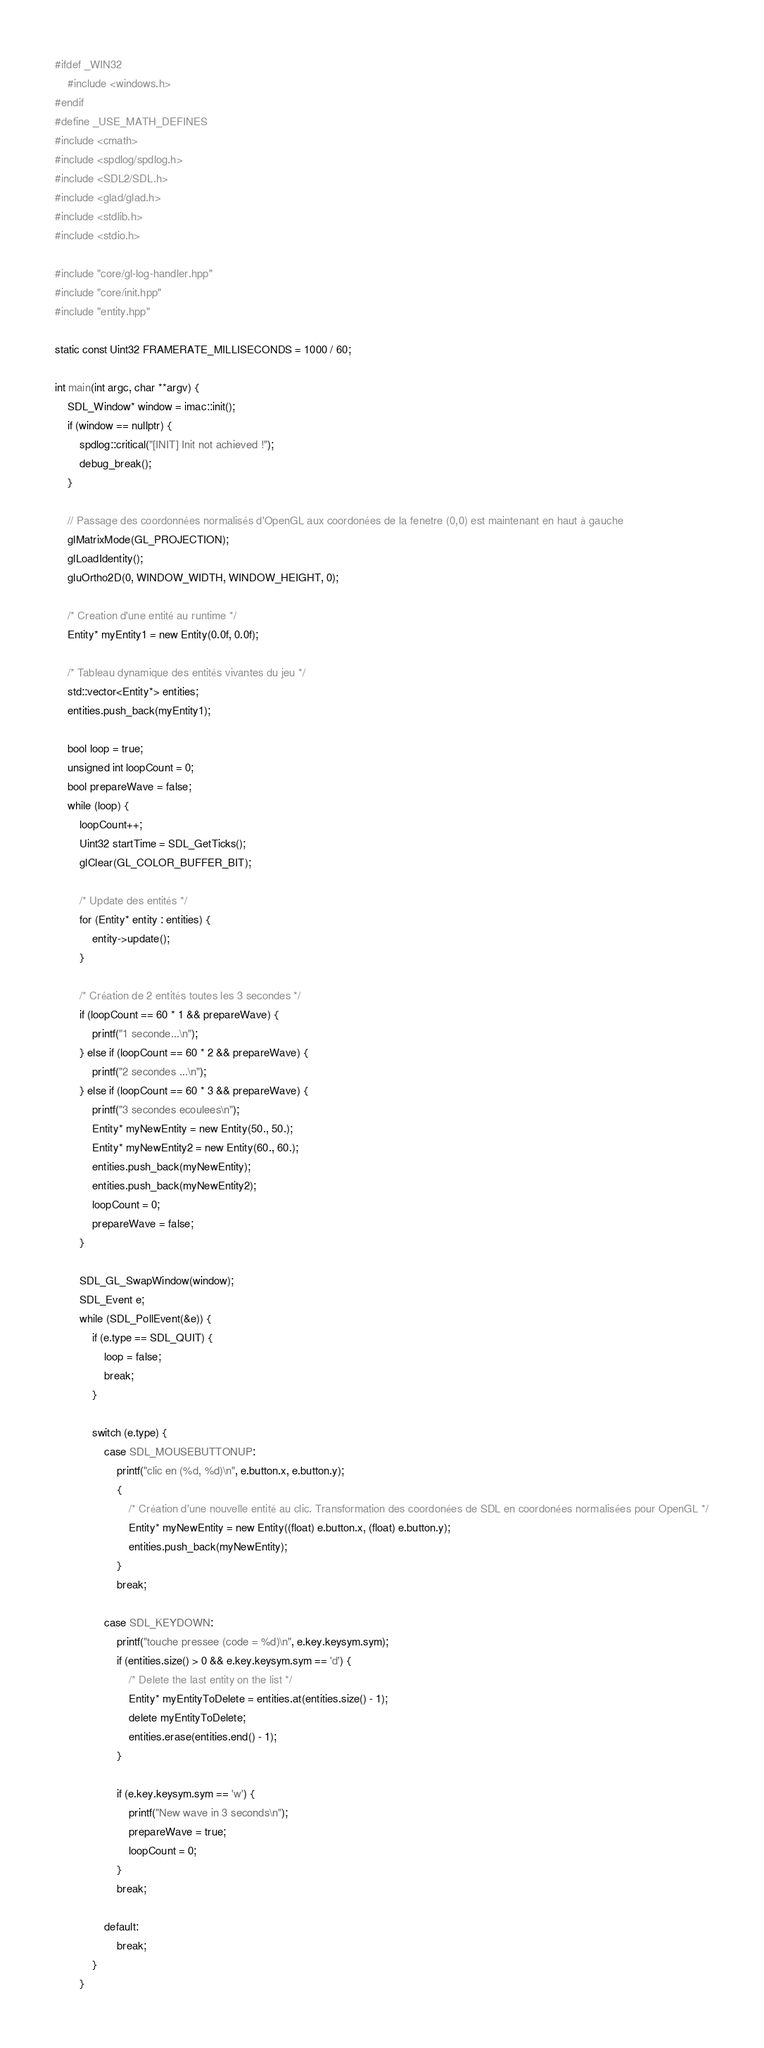<code> <loc_0><loc_0><loc_500><loc_500><_C++_>#ifdef _WIN32
    #include <windows.h>
#endif
#define _USE_MATH_DEFINES
#include <cmath>
#include <spdlog/spdlog.h>
#include <SDL2/SDL.h>
#include <glad/glad.h>
#include <stdlib.h>
#include <stdio.h>

#include "core/gl-log-handler.hpp"
#include "core/init.hpp"
#include "entity.hpp"

static const Uint32 FRAMERATE_MILLISECONDS = 1000 / 60;

int main(int argc, char **argv) {
    SDL_Window* window = imac::init();
    if (window == nullptr) {
        spdlog::critical("[INIT] Init not achieved !");
        debug_break();
    }

    // Passage des coordonnées normalisés d'OpenGL aux coordonées de la fenetre (0,0) est maintenant en haut à gauche
    glMatrixMode(GL_PROJECTION);
    glLoadIdentity();
    gluOrtho2D(0, WINDOW_WIDTH, WINDOW_HEIGHT, 0);

    /* Creation d'une entité au runtime */
    Entity* myEntity1 = new Entity(0.0f, 0.0f);

    /* Tableau dynamique des entités vivantes du jeu */
    std::vector<Entity*> entities;
    entities.push_back(myEntity1);

    bool loop = true;
    unsigned int loopCount = 0;
    bool prepareWave = false;
    while (loop) {
        loopCount++;
        Uint32 startTime = SDL_GetTicks();
        glClear(GL_COLOR_BUFFER_BIT);

        /* Update des entités */
        for (Entity* entity : entities) {
            entity->update();
        }

        /* Création de 2 entités toutes les 3 secondes */
        if (loopCount == 60 * 1 && prepareWave) {
            printf("1 seconde...\n");
        } else if (loopCount == 60 * 2 && prepareWave) {
            printf("2 secondes ...\n");
        } else if (loopCount == 60 * 3 && prepareWave) {
            printf("3 secondes ecoulees\n");
            Entity* myNewEntity = new Entity(50., 50.);
            Entity* myNewEntity2 = new Entity(60., 60.);
            entities.push_back(myNewEntity);
            entities.push_back(myNewEntity2);
            loopCount = 0;
            prepareWave = false;
        }

        SDL_GL_SwapWindow(window);
        SDL_Event e;
        while (SDL_PollEvent(&e)) {
            if (e.type == SDL_QUIT) {
                loop = false;
                break;
            }

            switch (e.type) {
                case SDL_MOUSEBUTTONUP:
                    printf("clic en (%d, %d)\n", e.button.x, e.button.y);
                    {
                        /* Création d'une nouvelle entité au clic. Transformation des coordonées de SDL en coordonées normalisées pour OpenGL */
                        Entity* myNewEntity = new Entity((float) e.button.x, (float) e.button.y);
                        entities.push_back(myNewEntity);
                    }
                    break;

                case SDL_KEYDOWN:
                    printf("touche pressee (code = %d)\n", e.key.keysym.sym);
                    if (entities.size() > 0 && e.key.keysym.sym == 'd') {
                        /* Delete the last entity on the list */
                        Entity* myEntityToDelete = entities.at(entities.size() - 1);
                        delete myEntityToDelete;
                        entities.erase(entities.end() - 1);
                    }

                    if (e.key.keysym.sym == 'w') {
                        printf("New wave in 3 seconds\n");
                        prepareWave = true;
                        loopCount = 0;
                    }
                    break;

                default:
                    break;
            }
        }
</code> 